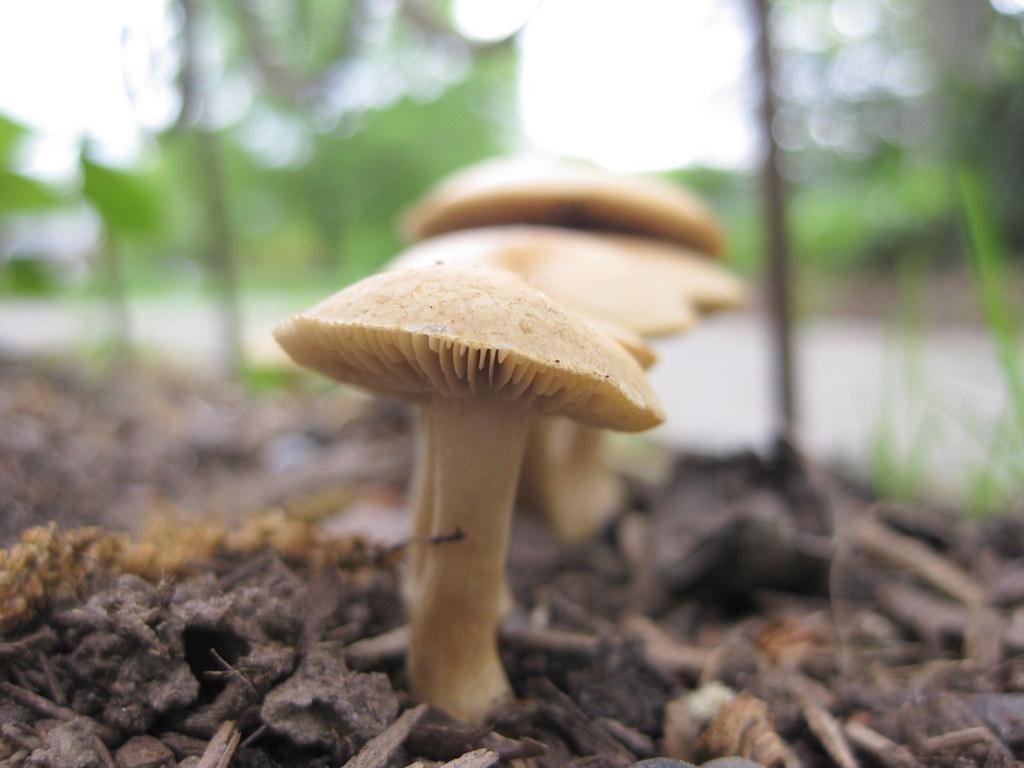Describe this image in one or two sentences. In the picture there are mushrooms present. 